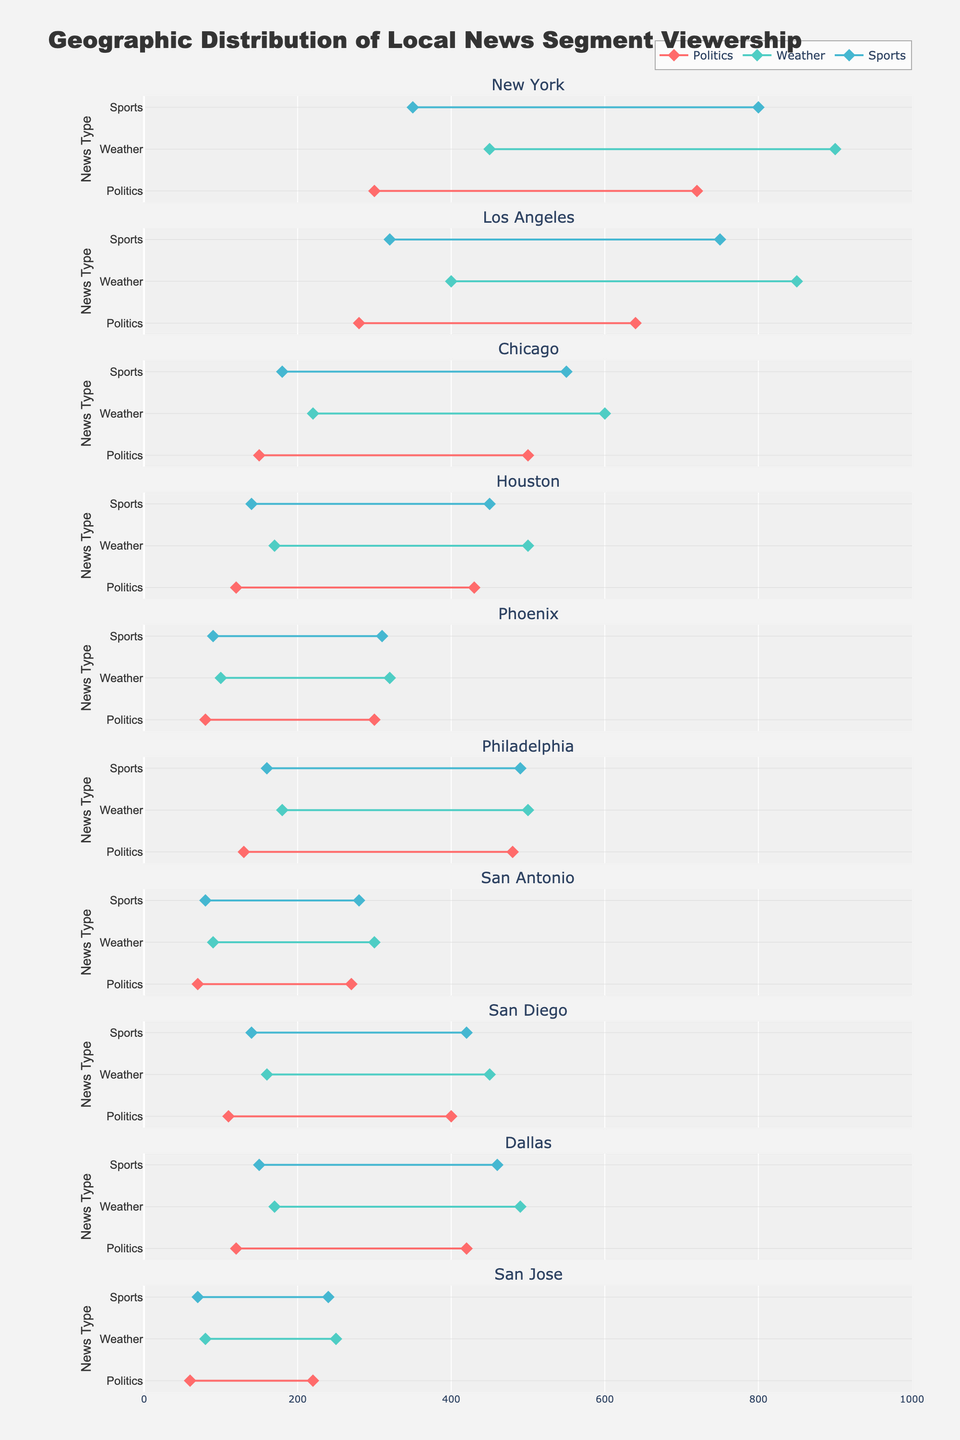What is the title of the figure? The title is typically positioned towards the top-center of the figure and is prominently displayed. From the layout settings, the title is "Geographic Distribution of Local News Segment Viewership".
Answer: Geographic Distribution of Local News Segment Viewership Which city shows the highest maximum viewership for the Weather segment? By examining the Weather segment for each city, we find the maximum value of viewership. For New York, it’s 900 thousand, which is the highest among all cities.
Answer: New York What is the range of viewership for Politics in Chicago? The range is calculated as the difference between the maximum and minimum viewership. For Politics in Chicago: 500 - 150 = 350 thousand.
Answer: 350 thousand Which local news type has the smallest viewership range in Phoenix? Calculate the range for each segment in Phoenix: Politics (300 - 80 = 220), Weather (320 - 100 = 220), Sports (310 - 90 = 220). All segments have the same smallest range of 220 thousand.
Answer: Politics, Weather, Sports What is the average maximum viewership for Sports segments across all cities? Sum the maximum viewership for Sports in all cities and divide by the number of cities: (800 + 750 + 550 + 450 + 310 + 490 + 280 + 420 + 460 + 240) / 10 = 4750 / 10 = 475 thousand.
Answer: 475 thousand How does the maximum viewership for Politics in Dallas compare to that in Houston? The maximum viewership for Politics in Dallas is 420 thousand and in Houston, it is 430 thousand. Thus, it is slightly lower in Dallas.
Answer: Lower in Dallas Which city has the largest difference in maximum viewership between Politics and Weather segments? Calculate the difference for each city and compare. New York: 900 - 720 = 180, Los Angeles: 850 - 640 = 210, Chicago: 600 - 500 = 100, Houston: 500 - 430 = 70, Phoenix: 320 - 300 = 20, Philadelphia: 500 - 480 = 20, San Antonio: 300 - 270 = 30, San Diego: 450 - 400 = 50, Dallas: 490 - 420 = 70, San Jose: 250 - 220 = 30. Los Angeles has the largest difference of 210 thousand.
Answer: Los Angeles What is the visual cue used to distinguish different news types in the plot? Different colors are used for each news type: Politics in a reddish color, Weather in a greenish color, and Sports in a bluish color, as indicated by the legend and the markers.
Answer: Colors Which city has the lowest minimum viewership for Sports segments? By looking at the minimum viewership values, San Jose has the lowest minimum viewership for Sports with 70 thousand.
Answer: San Jose 